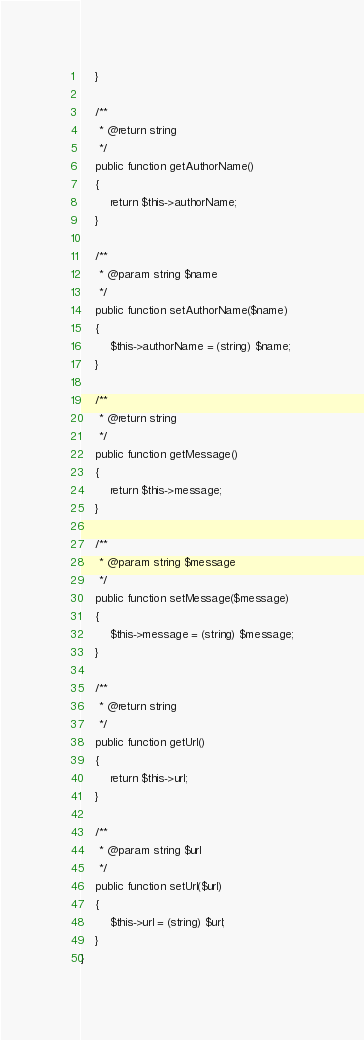<code> <loc_0><loc_0><loc_500><loc_500><_PHP_>    }

    /**
     * @return string
     */
    public function getAuthorName()
    {
        return $this->authorName;
    }

    /**
     * @param string $name
     */
    public function setAuthorName($name)
    {
        $this->authorName = (string) $name;
    }

    /**
     * @return string
     */
    public function getMessage()
    {
        return $this->message;
    }

    /**
     * @param string $message
     */
    public function setMessage($message)
    {
        $this->message = (string) $message;
    }

    /**
     * @return string
     */
    public function getUrl()
    {
        return $this->url;
    }

    /**
     * @param string $url
     */
    public function setUrl($url)
    {
        $this->url = (string) $url;
    }
}
</code> 